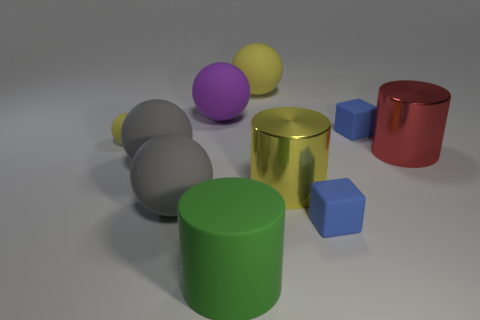There is a green cylinder that is made of the same material as the purple ball; what is its size?
Your answer should be compact. Large. Are there any other things that are the same color as the small sphere?
Your response must be concise. Yes. Do the metal thing in front of the red shiny thing and the sphere that is to the right of the large matte cylinder have the same color?
Provide a succinct answer. Yes. The sphere right of the purple matte object is what color?
Offer a terse response. Yellow. There is a thing that is behind the purple rubber ball; is it the same size as the big green cylinder?
Your answer should be compact. Yes. Is the number of rubber blocks less than the number of small red metallic blocks?
Your answer should be very brief. No. There is a large matte object that is the same color as the tiny matte ball; what is its shape?
Provide a short and direct response. Sphere. There is a big purple sphere; what number of yellow rubber objects are behind it?
Keep it short and to the point. 1. Is the shape of the small yellow rubber thing the same as the purple rubber object?
Ensure brevity in your answer.  Yes. What number of rubber objects are both behind the green rubber cylinder and right of the tiny rubber ball?
Keep it short and to the point. 6. 